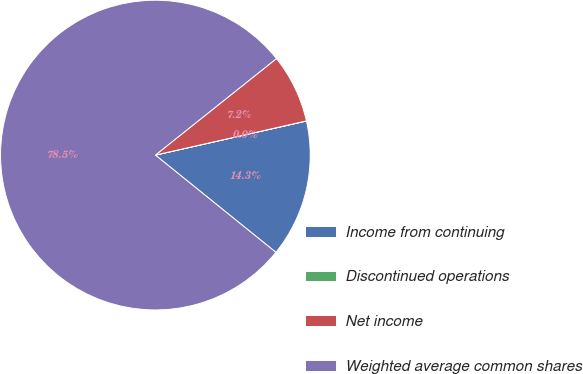Convert chart. <chart><loc_0><loc_0><loc_500><loc_500><pie_chart><fcel>Income from continuing<fcel>Discontinued operations<fcel>Net income<fcel>Weighted average common shares<nl><fcel>14.34%<fcel>0.01%<fcel>7.17%<fcel>78.48%<nl></chart> 